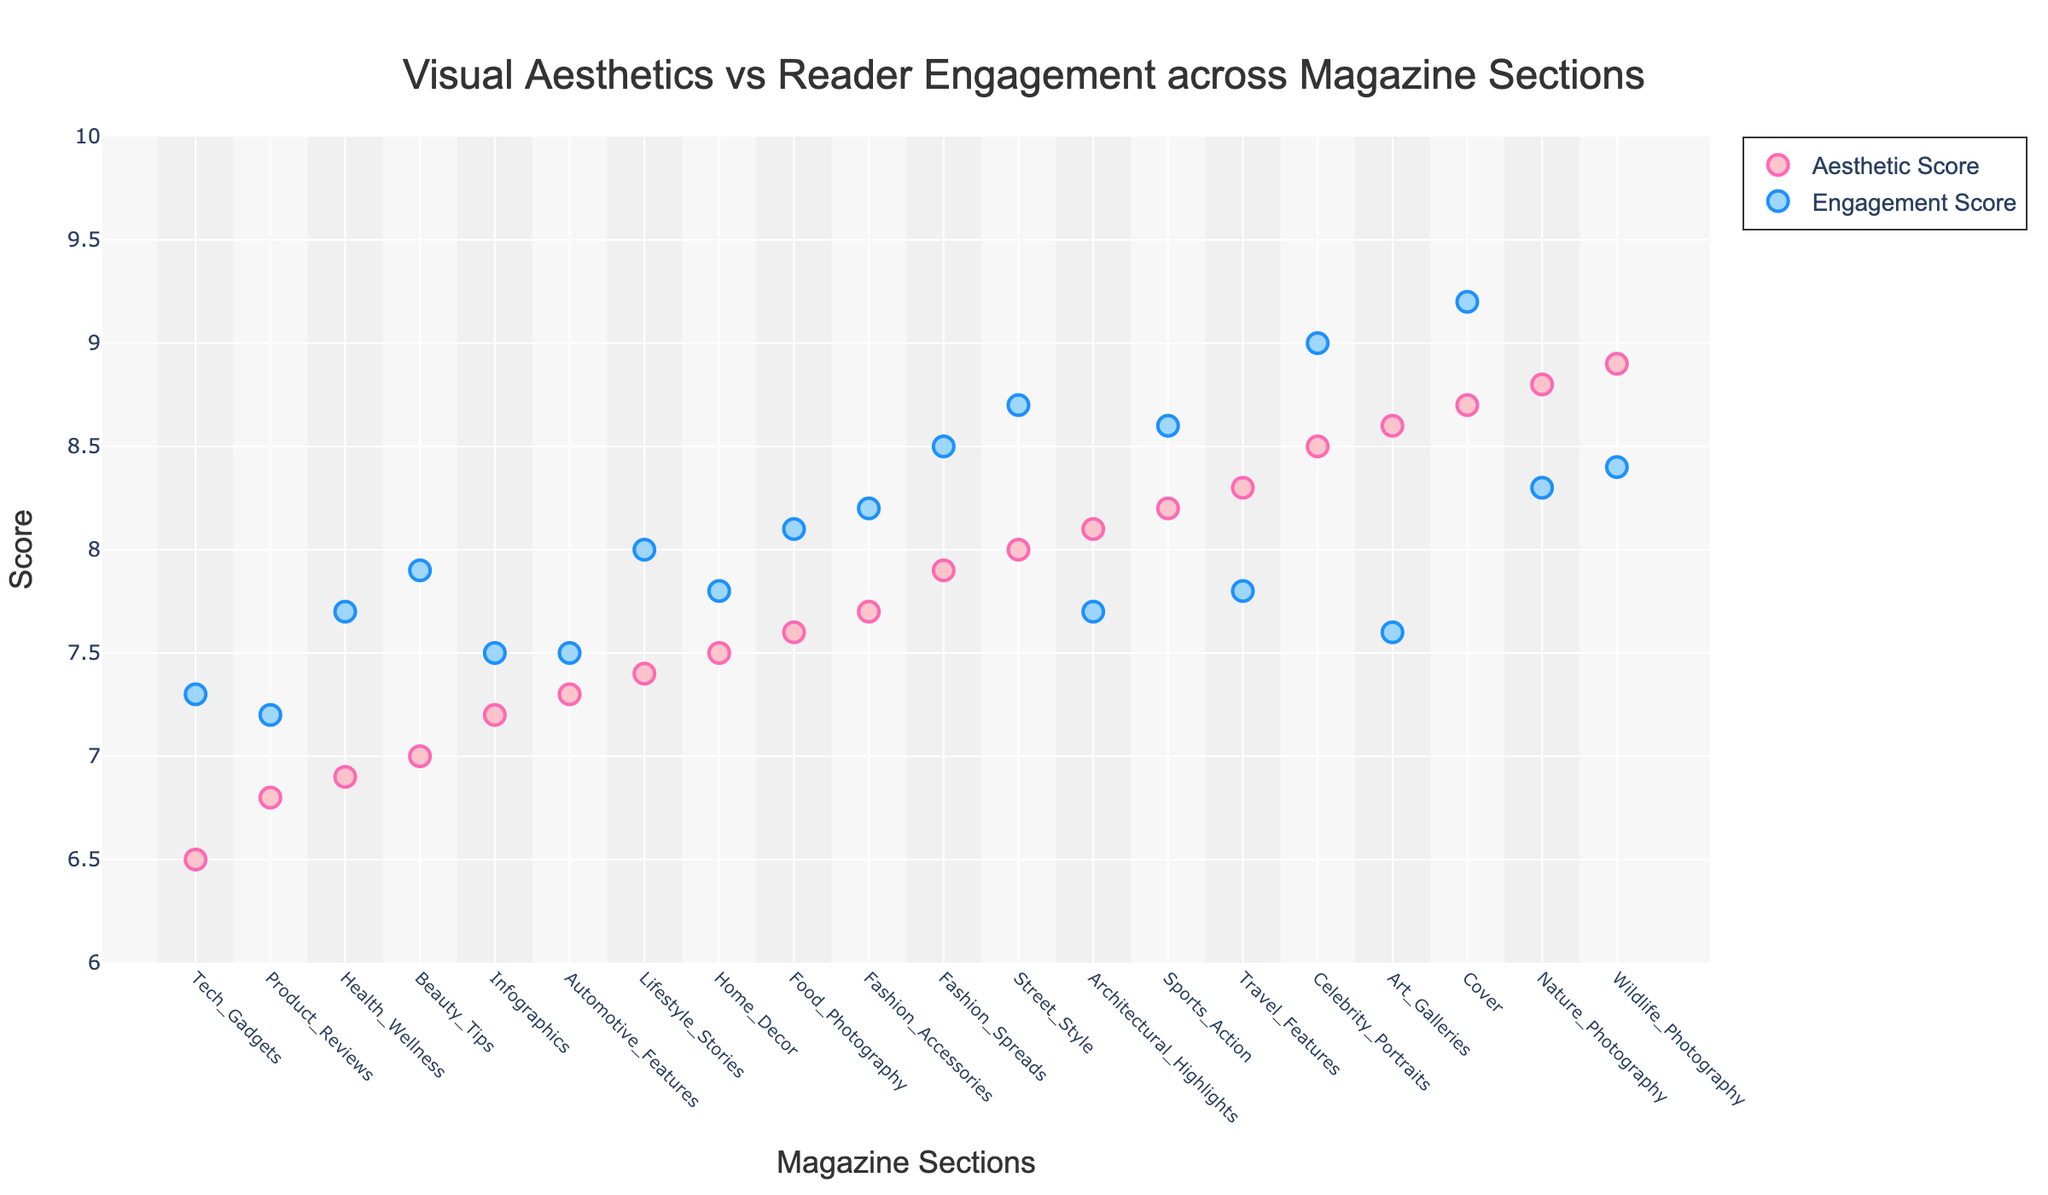What is the title of the plot? The title of the plot is typically located at the top of the figure. From the given code, the title is set as 'Visual Aesthetics vs Reader Engagement across Magazine Sections'.
Answer: Visual Aesthetics vs Reader Engagement across Magazine Sections Which magazine section has the highest Aesthetic Score? By observing the y-axis corresponding to the "Aesthetic Score" and finding the highest value point, we can determine that "Wildlife Photography" has the highest Aesthetic Score of 8.9.
Answer: Wildlife Photography Which magazine section has the lowest Engagement Score? By examining the y-axis corresponding to the "Engagement Score" and finding the lowest value point, we can determine that "Product Reviews" has the lowest Engagement Score of 7.2.
Answer: Product Reviews Compare the Aesthetic Score and Engagement Score for the Cover section. Looking at the x-axis for the "Cover" section and checking its points on the y-axis, the Aesthetic Score is 8.7 and the Engagement Score is 9.2.
Answer: 8.7, 9.2 What is the average Aesthetic Score of the fashion-related sections ("Fashion_Spreads" and "Fashion_Accessories")? First, we identify the Aesthetic Scores: "Fashion_Spreads" has 7.9, and "Fashion_Accessories" has 7.7. Then, we calculate the average: (7.9 + 7.7) / 2 = 7.8.
Answer: 7.8 Which section has a higher Engagement Score, "Tech Gadgets" or "Home Decor"? By comparing the Engagement Scores on the y-axis, "Tech Gadgets" has a score of 7.3, while "Home Decor" has a score of 7.8. Since 7.8 is greater than 7.3, "Home Decor" has a higher Engagement Score.
Answer: Home Decor What is the difference in Engagement Score between the sections with the highest and lowest Engagement Scores? The highest Engagement Score is 9.2 ("Cover"), and the lowest is 7.2 ("Product Reviews"). The difference is 9.2 - 7.2 = 2.0.
Answer: 2.0 How many sections have an Aesthetic Score higher than 8.0? By counting the number of points on the plot with an Aesthetic Score greater than 8.0, we identify 9 sections ("Cover", "Celebrity_Portraits", "Nature_Photography", "Sports_Action", "Art_Galleries", "Wildlife_Photography", "Street_Style", "Architectural_Highlights", and "Travel_Features").
Answer: 9 Which section has a greater gap between Aesthetic Score and Engagement Score, "Food Photography" or "Health Wellness"? "Food Photography" has an Aesthetic Score of 7.6 and an Engagement Score of 8.1 (gap = 8.1 - 7.6 = 0.5). "Health Wellness" has an Aesthetic Score of 6.9 and an Engagement Score of 7.7 (gap = 7.7 - 6.9 = 0.8). Therefore, "Health Wellness" has a greater gap.
Answer: Health Wellness What is the combined score (sum of Aesthetic and Engagement Scores) for the "Celebrity Portraits" section? The Aesthetic Score for "Celebrity Portraits" is 8.5, and its Engagement Score is 9.0. The sum is 8.5 + 9.0 = 17.5.
Answer: 17.5 